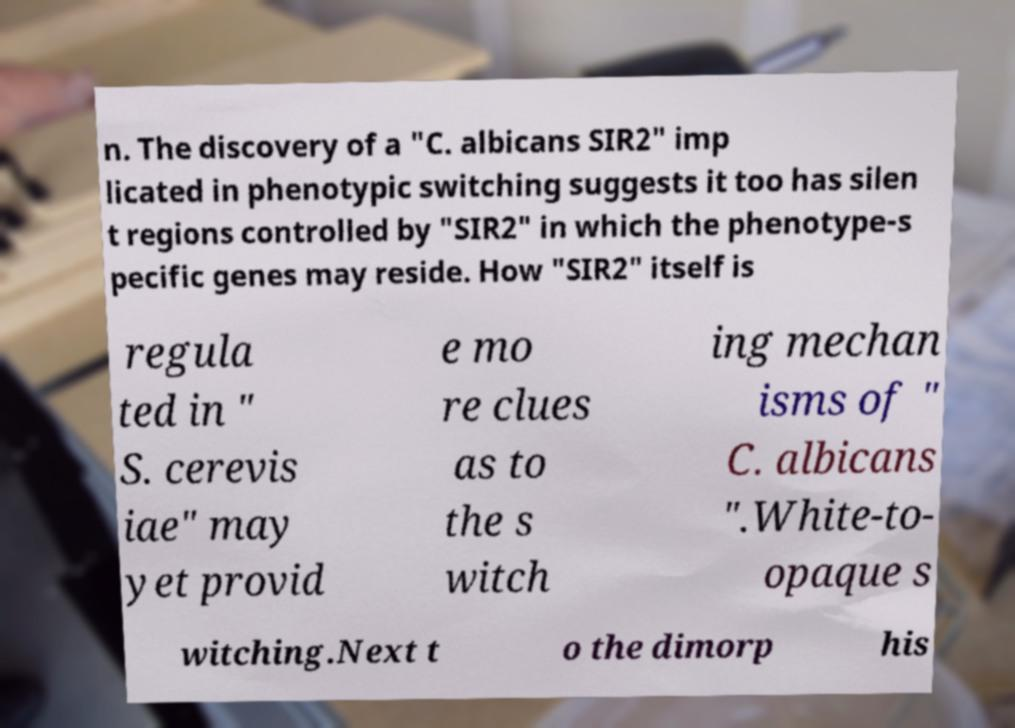There's text embedded in this image that I need extracted. Can you transcribe it verbatim? n. The discovery of a "C. albicans SIR2" imp licated in phenotypic switching suggests it too has silen t regions controlled by "SIR2" in which the phenotype-s pecific genes may reside. How "SIR2" itself is regula ted in " S. cerevis iae" may yet provid e mo re clues as to the s witch ing mechan isms of " C. albicans ".White-to- opaque s witching.Next t o the dimorp his 